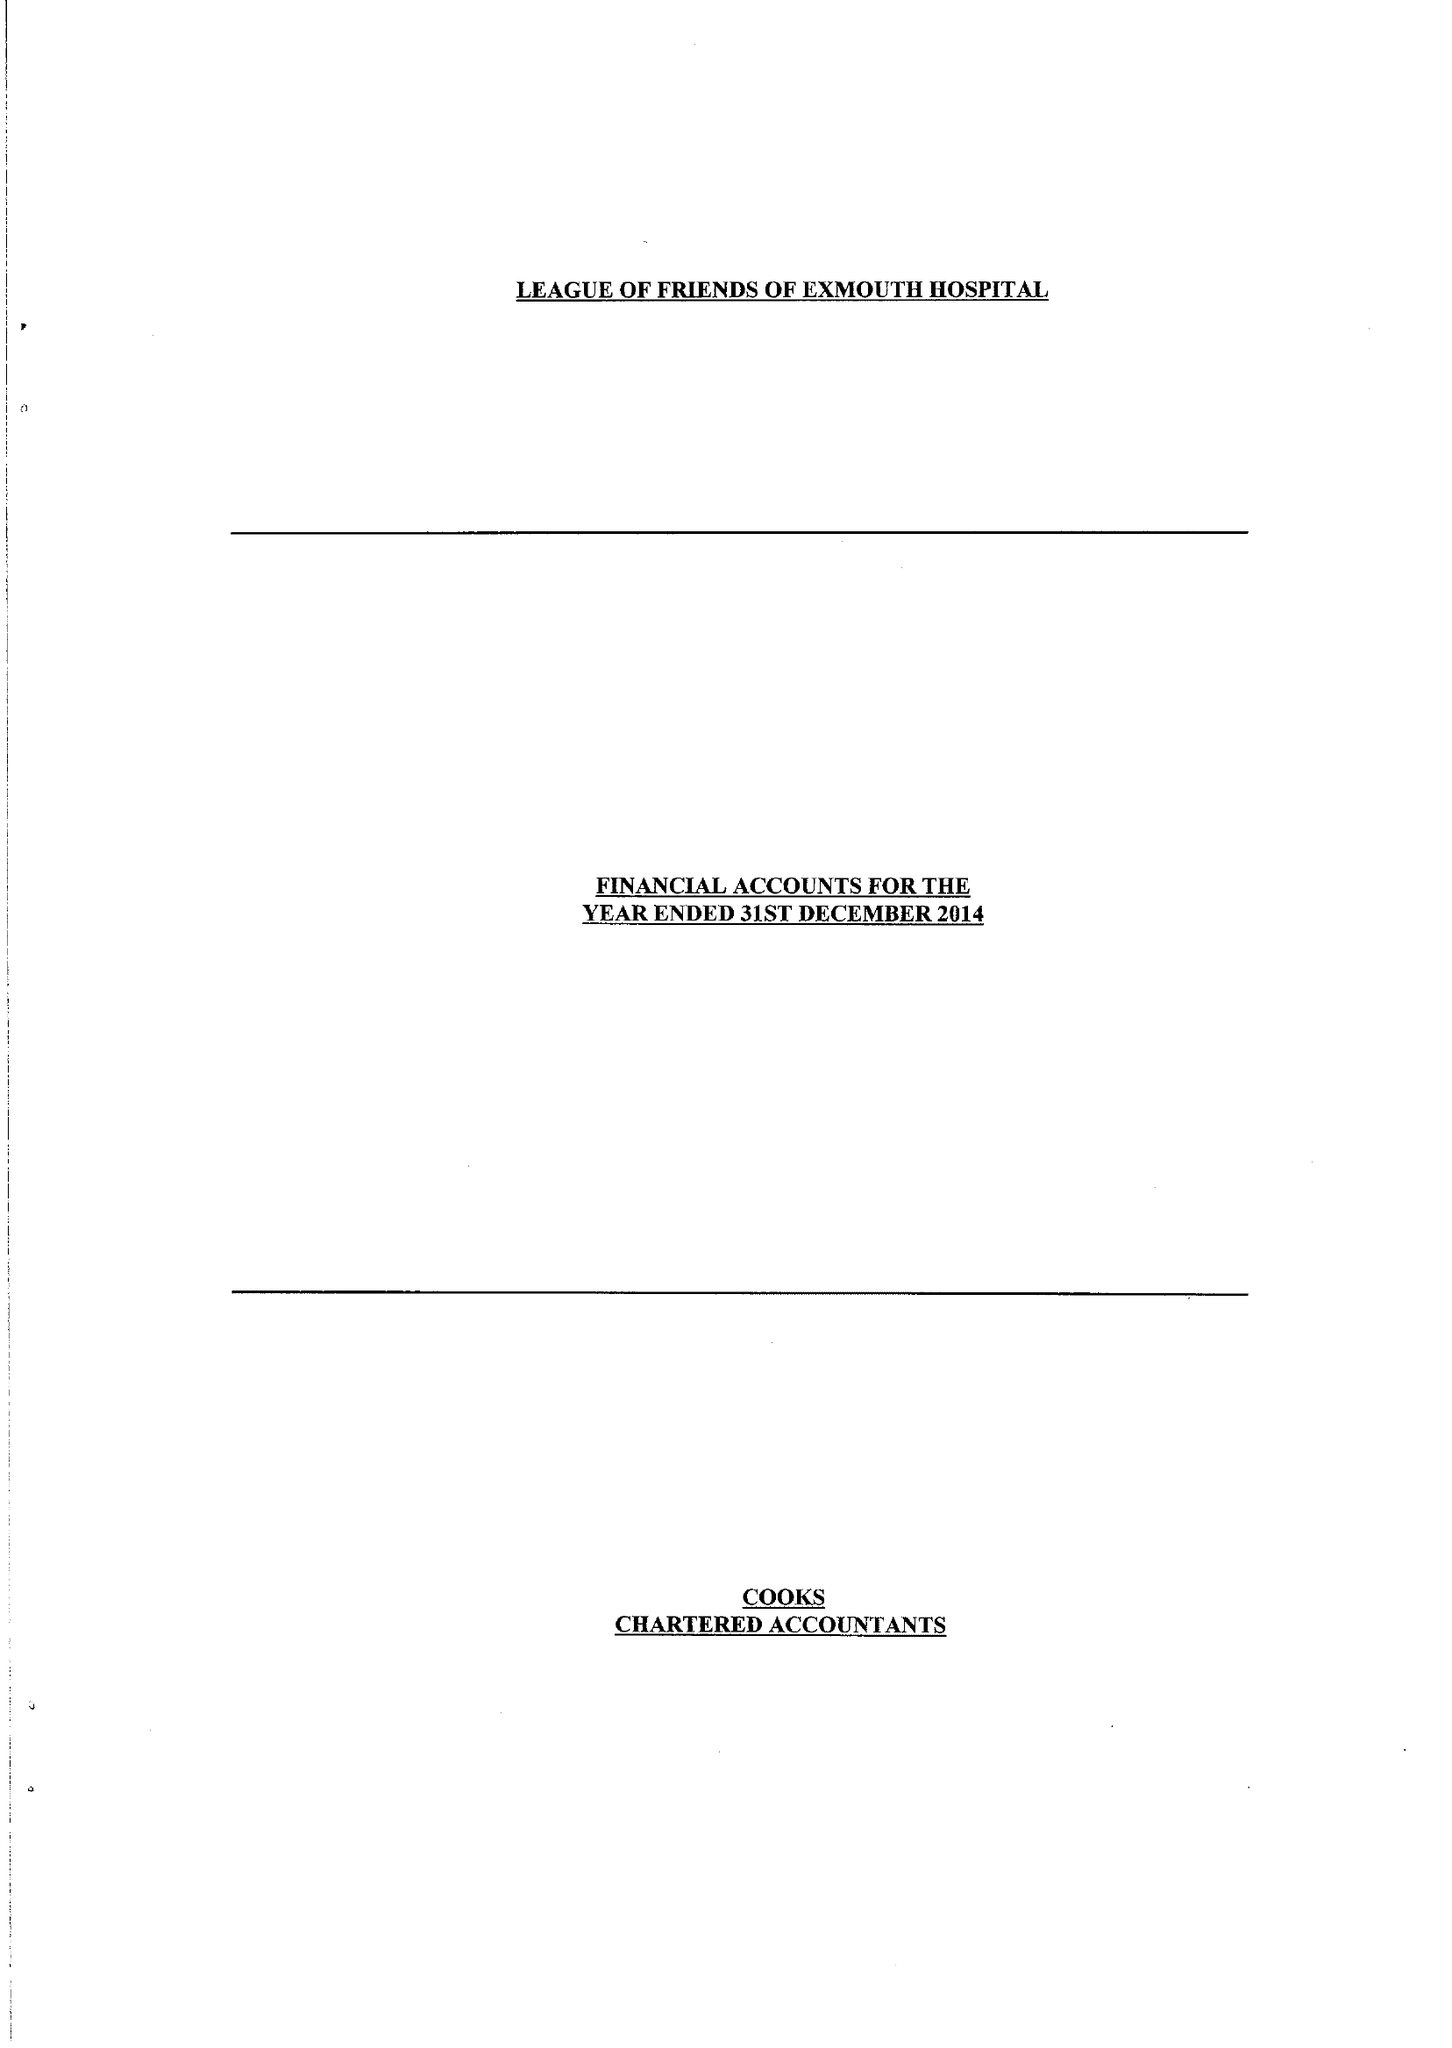What is the value for the address__street_line?
Answer the question using a single word or phrase. SALTERTON ROAD 